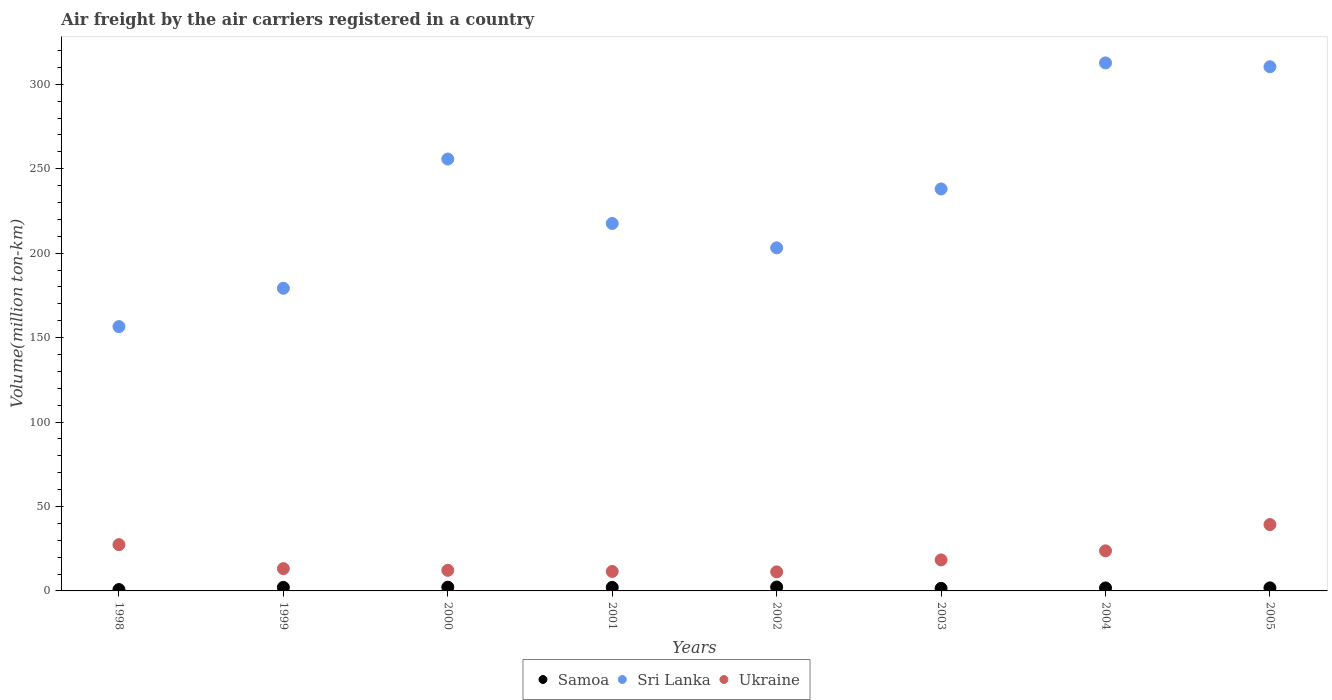How many different coloured dotlines are there?
Provide a short and direct response. 3. Is the number of dotlines equal to the number of legend labels?
Provide a succinct answer. Yes. What is the volume of the air carriers in Ukraine in 2001?
Your answer should be very brief. 11.52. Across all years, what is the maximum volume of the air carriers in Samoa?
Your answer should be very brief. 2.31. Across all years, what is the minimum volume of the air carriers in Sri Lanka?
Provide a succinct answer. 156.5. In which year was the volume of the air carriers in Samoa maximum?
Offer a very short reply. 2002. What is the total volume of the air carriers in Ukraine in the graph?
Keep it short and to the point. 156.99. What is the difference between the volume of the air carriers in Sri Lanka in 2001 and that in 2002?
Give a very brief answer. 14.44. What is the difference between the volume of the air carriers in Ukraine in 1998 and the volume of the air carriers in Samoa in 2002?
Your answer should be very brief. 25.09. What is the average volume of the air carriers in Samoa per year?
Your answer should be compact. 1.82. In the year 1999, what is the difference between the volume of the air carriers in Ukraine and volume of the air carriers in Samoa?
Keep it short and to the point. 11.1. What is the ratio of the volume of the air carriers in Samoa in 1999 to that in 2000?
Keep it short and to the point. 0.94. Is the volume of the air carriers in Ukraine in 1999 less than that in 2005?
Ensure brevity in your answer.  Yes. Is the difference between the volume of the air carriers in Ukraine in 2003 and 2004 greater than the difference between the volume of the air carriers in Samoa in 2003 and 2004?
Keep it short and to the point. No. What is the difference between the highest and the second highest volume of the air carriers in Sri Lanka?
Offer a terse response. 2.26. What is the difference between the highest and the lowest volume of the air carriers in Ukraine?
Provide a succinct answer. 28.01. In how many years, is the volume of the air carriers in Ukraine greater than the average volume of the air carriers in Ukraine taken over all years?
Keep it short and to the point. 3. Is it the case that in every year, the sum of the volume of the air carriers in Sri Lanka and volume of the air carriers in Samoa  is greater than the volume of the air carriers in Ukraine?
Keep it short and to the point. Yes. How many dotlines are there?
Offer a very short reply. 3. Are the values on the major ticks of Y-axis written in scientific E-notation?
Give a very brief answer. No. Does the graph contain any zero values?
Make the answer very short. No. Where does the legend appear in the graph?
Ensure brevity in your answer.  Bottom center. How many legend labels are there?
Give a very brief answer. 3. What is the title of the graph?
Offer a terse response. Air freight by the air carriers registered in a country. Does "Sub-Saharan Africa (developing only)" appear as one of the legend labels in the graph?
Make the answer very short. No. What is the label or title of the Y-axis?
Your answer should be very brief. Volume(million ton-km). What is the Volume(million ton-km) in Samoa in 1998?
Keep it short and to the point. 0.8. What is the Volume(million ton-km) of Sri Lanka in 1998?
Provide a short and direct response. 156.5. What is the Volume(million ton-km) in Ukraine in 1998?
Offer a terse response. 27.4. What is the Volume(million ton-km) of Samoa in 1999?
Make the answer very short. 2.1. What is the Volume(million ton-km) in Sri Lanka in 1999?
Provide a short and direct response. 179.2. What is the Volume(million ton-km) of Ukraine in 1999?
Your answer should be compact. 13.2. What is the Volume(million ton-km) of Samoa in 2000?
Your answer should be very brief. 2.23. What is the Volume(million ton-km) of Sri Lanka in 2000?
Your answer should be compact. 255.71. What is the Volume(million ton-km) in Ukraine in 2000?
Keep it short and to the point. 12.2. What is the Volume(million ton-km) in Samoa in 2001?
Offer a very short reply. 2.08. What is the Volume(million ton-km) in Sri Lanka in 2001?
Offer a very short reply. 217.57. What is the Volume(million ton-km) in Ukraine in 2001?
Keep it short and to the point. 11.52. What is the Volume(million ton-km) in Samoa in 2002?
Your answer should be very brief. 2.31. What is the Volume(million ton-km) in Sri Lanka in 2002?
Provide a succinct answer. 203.13. What is the Volume(million ton-km) in Ukraine in 2002?
Give a very brief answer. 11.28. What is the Volume(million ton-km) in Samoa in 2003?
Your response must be concise. 1.5. What is the Volume(million ton-km) of Sri Lanka in 2003?
Your answer should be compact. 238.01. What is the Volume(million ton-km) of Ukraine in 2003?
Your response must be concise. 18.36. What is the Volume(million ton-km) of Samoa in 2004?
Your response must be concise. 1.75. What is the Volume(million ton-km) in Sri Lanka in 2004?
Offer a very short reply. 312.63. What is the Volume(million ton-km) in Ukraine in 2004?
Ensure brevity in your answer.  23.73. What is the Volume(million ton-km) of Samoa in 2005?
Your response must be concise. 1.81. What is the Volume(million ton-km) of Sri Lanka in 2005?
Keep it short and to the point. 310.36. What is the Volume(million ton-km) of Ukraine in 2005?
Keep it short and to the point. 39.29. Across all years, what is the maximum Volume(million ton-km) of Samoa?
Offer a terse response. 2.31. Across all years, what is the maximum Volume(million ton-km) of Sri Lanka?
Your answer should be very brief. 312.63. Across all years, what is the maximum Volume(million ton-km) of Ukraine?
Your answer should be compact. 39.29. Across all years, what is the minimum Volume(million ton-km) in Samoa?
Provide a short and direct response. 0.8. Across all years, what is the minimum Volume(million ton-km) in Sri Lanka?
Make the answer very short. 156.5. Across all years, what is the minimum Volume(million ton-km) of Ukraine?
Provide a succinct answer. 11.28. What is the total Volume(million ton-km) in Samoa in the graph?
Make the answer very short. 14.58. What is the total Volume(million ton-km) of Sri Lanka in the graph?
Keep it short and to the point. 1873.1. What is the total Volume(million ton-km) of Ukraine in the graph?
Offer a terse response. 156.99. What is the difference between the Volume(million ton-km) in Samoa in 1998 and that in 1999?
Provide a succinct answer. -1.3. What is the difference between the Volume(million ton-km) in Sri Lanka in 1998 and that in 1999?
Keep it short and to the point. -22.7. What is the difference between the Volume(million ton-km) of Samoa in 1998 and that in 2000?
Offer a terse response. -1.43. What is the difference between the Volume(million ton-km) in Sri Lanka in 1998 and that in 2000?
Offer a very short reply. -99.21. What is the difference between the Volume(million ton-km) of Ukraine in 1998 and that in 2000?
Make the answer very short. 15.21. What is the difference between the Volume(million ton-km) in Samoa in 1998 and that in 2001?
Provide a short and direct response. -1.28. What is the difference between the Volume(million ton-km) of Sri Lanka in 1998 and that in 2001?
Provide a short and direct response. -61.07. What is the difference between the Volume(million ton-km) of Ukraine in 1998 and that in 2001?
Keep it short and to the point. 15.88. What is the difference between the Volume(million ton-km) of Samoa in 1998 and that in 2002?
Provide a short and direct response. -1.51. What is the difference between the Volume(million ton-km) in Sri Lanka in 1998 and that in 2002?
Your answer should be compact. -46.63. What is the difference between the Volume(million ton-km) of Ukraine in 1998 and that in 2002?
Offer a very short reply. 16.12. What is the difference between the Volume(million ton-km) of Samoa in 1998 and that in 2003?
Provide a short and direct response. -0.69. What is the difference between the Volume(million ton-km) of Sri Lanka in 1998 and that in 2003?
Provide a short and direct response. -81.51. What is the difference between the Volume(million ton-km) of Ukraine in 1998 and that in 2003?
Your answer should be compact. 9.04. What is the difference between the Volume(million ton-km) of Samoa in 1998 and that in 2004?
Your response must be concise. -0.95. What is the difference between the Volume(million ton-km) in Sri Lanka in 1998 and that in 2004?
Provide a succinct answer. -156.13. What is the difference between the Volume(million ton-km) of Ukraine in 1998 and that in 2004?
Your answer should be compact. 3.67. What is the difference between the Volume(million ton-km) of Samoa in 1998 and that in 2005?
Your answer should be very brief. -1.01. What is the difference between the Volume(million ton-km) in Sri Lanka in 1998 and that in 2005?
Offer a very short reply. -153.86. What is the difference between the Volume(million ton-km) of Ukraine in 1998 and that in 2005?
Your response must be concise. -11.89. What is the difference between the Volume(million ton-km) of Samoa in 1999 and that in 2000?
Offer a terse response. -0.13. What is the difference between the Volume(million ton-km) in Sri Lanka in 1999 and that in 2000?
Provide a succinct answer. -76.51. What is the difference between the Volume(million ton-km) in Ukraine in 1999 and that in 2000?
Ensure brevity in your answer.  1. What is the difference between the Volume(million ton-km) of Samoa in 1999 and that in 2001?
Offer a very short reply. 0.02. What is the difference between the Volume(million ton-km) of Sri Lanka in 1999 and that in 2001?
Ensure brevity in your answer.  -38.37. What is the difference between the Volume(million ton-km) in Ukraine in 1999 and that in 2001?
Keep it short and to the point. 1.68. What is the difference between the Volume(million ton-km) of Samoa in 1999 and that in 2002?
Provide a succinct answer. -0.21. What is the difference between the Volume(million ton-km) of Sri Lanka in 1999 and that in 2002?
Your answer should be very brief. -23.93. What is the difference between the Volume(million ton-km) in Ukraine in 1999 and that in 2002?
Provide a short and direct response. 1.92. What is the difference between the Volume(million ton-km) in Samoa in 1999 and that in 2003?
Provide a succinct answer. 0.6. What is the difference between the Volume(million ton-km) of Sri Lanka in 1999 and that in 2003?
Ensure brevity in your answer.  -58.81. What is the difference between the Volume(million ton-km) in Ukraine in 1999 and that in 2003?
Give a very brief answer. -5.16. What is the difference between the Volume(million ton-km) of Sri Lanka in 1999 and that in 2004?
Provide a short and direct response. -133.43. What is the difference between the Volume(million ton-km) in Ukraine in 1999 and that in 2004?
Provide a succinct answer. -10.53. What is the difference between the Volume(million ton-km) in Samoa in 1999 and that in 2005?
Your response must be concise. 0.29. What is the difference between the Volume(million ton-km) of Sri Lanka in 1999 and that in 2005?
Ensure brevity in your answer.  -131.16. What is the difference between the Volume(million ton-km) of Ukraine in 1999 and that in 2005?
Keep it short and to the point. -26.09. What is the difference between the Volume(million ton-km) in Samoa in 2000 and that in 2001?
Give a very brief answer. 0.14. What is the difference between the Volume(million ton-km) in Sri Lanka in 2000 and that in 2001?
Ensure brevity in your answer.  38.14. What is the difference between the Volume(million ton-km) in Ukraine in 2000 and that in 2001?
Your response must be concise. 0.67. What is the difference between the Volume(million ton-km) of Samoa in 2000 and that in 2002?
Ensure brevity in your answer.  -0.09. What is the difference between the Volume(million ton-km) of Sri Lanka in 2000 and that in 2002?
Give a very brief answer. 52.58. What is the difference between the Volume(million ton-km) in Ukraine in 2000 and that in 2002?
Offer a very short reply. 0.91. What is the difference between the Volume(million ton-km) in Samoa in 2000 and that in 2003?
Keep it short and to the point. 0.73. What is the difference between the Volume(million ton-km) of Sri Lanka in 2000 and that in 2003?
Give a very brief answer. 17.7. What is the difference between the Volume(million ton-km) of Ukraine in 2000 and that in 2003?
Ensure brevity in your answer.  -6.16. What is the difference between the Volume(million ton-km) of Samoa in 2000 and that in 2004?
Offer a very short reply. 0.48. What is the difference between the Volume(million ton-km) in Sri Lanka in 2000 and that in 2004?
Give a very brief answer. -56.92. What is the difference between the Volume(million ton-km) in Ukraine in 2000 and that in 2004?
Keep it short and to the point. -11.54. What is the difference between the Volume(million ton-km) of Samoa in 2000 and that in 2005?
Make the answer very short. 0.42. What is the difference between the Volume(million ton-km) in Sri Lanka in 2000 and that in 2005?
Ensure brevity in your answer.  -54.65. What is the difference between the Volume(million ton-km) in Ukraine in 2000 and that in 2005?
Your answer should be compact. -27.1. What is the difference between the Volume(million ton-km) in Samoa in 2001 and that in 2002?
Ensure brevity in your answer.  -0.23. What is the difference between the Volume(million ton-km) in Sri Lanka in 2001 and that in 2002?
Your answer should be compact. 14.44. What is the difference between the Volume(million ton-km) in Ukraine in 2001 and that in 2002?
Make the answer very short. 0.24. What is the difference between the Volume(million ton-km) of Samoa in 2001 and that in 2003?
Your answer should be compact. 0.59. What is the difference between the Volume(million ton-km) of Sri Lanka in 2001 and that in 2003?
Make the answer very short. -20.44. What is the difference between the Volume(million ton-km) in Ukraine in 2001 and that in 2003?
Your answer should be compact. -6.84. What is the difference between the Volume(million ton-km) of Samoa in 2001 and that in 2004?
Provide a succinct answer. 0.33. What is the difference between the Volume(million ton-km) in Sri Lanka in 2001 and that in 2004?
Provide a succinct answer. -95.06. What is the difference between the Volume(million ton-km) of Ukraine in 2001 and that in 2004?
Your response must be concise. -12.21. What is the difference between the Volume(million ton-km) in Samoa in 2001 and that in 2005?
Provide a succinct answer. 0.27. What is the difference between the Volume(million ton-km) of Sri Lanka in 2001 and that in 2005?
Your answer should be very brief. -92.8. What is the difference between the Volume(million ton-km) of Ukraine in 2001 and that in 2005?
Your answer should be very brief. -27.77. What is the difference between the Volume(million ton-km) in Samoa in 2002 and that in 2003?
Keep it short and to the point. 0.82. What is the difference between the Volume(million ton-km) in Sri Lanka in 2002 and that in 2003?
Provide a short and direct response. -34.88. What is the difference between the Volume(million ton-km) of Ukraine in 2002 and that in 2003?
Your answer should be very brief. -7.08. What is the difference between the Volume(million ton-km) in Samoa in 2002 and that in 2004?
Offer a very short reply. 0.56. What is the difference between the Volume(million ton-km) in Sri Lanka in 2002 and that in 2004?
Your response must be concise. -109.5. What is the difference between the Volume(million ton-km) of Ukraine in 2002 and that in 2004?
Offer a terse response. -12.45. What is the difference between the Volume(million ton-km) in Samoa in 2002 and that in 2005?
Offer a terse response. 0.5. What is the difference between the Volume(million ton-km) of Sri Lanka in 2002 and that in 2005?
Offer a terse response. -107.24. What is the difference between the Volume(million ton-km) in Ukraine in 2002 and that in 2005?
Your answer should be compact. -28.01. What is the difference between the Volume(million ton-km) of Samoa in 2003 and that in 2004?
Ensure brevity in your answer.  -0.26. What is the difference between the Volume(million ton-km) of Sri Lanka in 2003 and that in 2004?
Offer a very short reply. -74.62. What is the difference between the Volume(million ton-km) of Ukraine in 2003 and that in 2004?
Ensure brevity in your answer.  -5.38. What is the difference between the Volume(million ton-km) of Samoa in 2003 and that in 2005?
Provide a short and direct response. -0.31. What is the difference between the Volume(million ton-km) in Sri Lanka in 2003 and that in 2005?
Make the answer very short. -72.35. What is the difference between the Volume(million ton-km) in Ukraine in 2003 and that in 2005?
Provide a short and direct response. -20.93. What is the difference between the Volume(million ton-km) in Samoa in 2004 and that in 2005?
Offer a terse response. -0.06. What is the difference between the Volume(million ton-km) in Sri Lanka in 2004 and that in 2005?
Provide a short and direct response. 2.27. What is the difference between the Volume(million ton-km) of Ukraine in 2004 and that in 2005?
Your response must be concise. -15.56. What is the difference between the Volume(million ton-km) in Samoa in 1998 and the Volume(million ton-km) in Sri Lanka in 1999?
Make the answer very short. -178.4. What is the difference between the Volume(million ton-km) of Samoa in 1998 and the Volume(million ton-km) of Ukraine in 1999?
Your answer should be very brief. -12.4. What is the difference between the Volume(million ton-km) of Sri Lanka in 1998 and the Volume(million ton-km) of Ukraine in 1999?
Your answer should be compact. 143.3. What is the difference between the Volume(million ton-km) in Samoa in 1998 and the Volume(million ton-km) in Sri Lanka in 2000?
Provide a succinct answer. -254.91. What is the difference between the Volume(million ton-km) in Samoa in 1998 and the Volume(million ton-km) in Ukraine in 2000?
Keep it short and to the point. -11.39. What is the difference between the Volume(million ton-km) in Sri Lanka in 1998 and the Volume(million ton-km) in Ukraine in 2000?
Your answer should be very brief. 144.31. What is the difference between the Volume(million ton-km) of Samoa in 1998 and the Volume(million ton-km) of Sri Lanka in 2001?
Your answer should be very brief. -216.77. What is the difference between the Volume(million ton-km) in Samoa in 1998 and the Volume(million ton-km) in Ukraine in 2001?
Provide a short and direct response. -10.72. What is the difference between the Volume(million ton-km) of Sri Lanka in 1998 and the Volume(million ton-km) of Ukraine in 2001?
Ensure brevity in your answer.  144.98. What is the difference between the Volume(million ton-km) in Samoa in 1998 and the Volume(million ton-km) in Sri Lanka in 2002?
Give a very brief answer. -202.33. What is the difference between the Volume(million ton-km) of Samoa in 1998 and the Volume(million ton-km) of Ukraine in 2002?
Your response must be concise. -10.48. What is the difference between the Volume(million ton-km) in Sri Lanka in 1998 and the Volume(million ton-km) in Ukraine in 2002?
Provide a short and direct response. 145.22. What is the difference between the Volume(million ton-km) of Samoa in 1998 and the Volume(million ton-km) of Sri Lanka in 2003?
Give a very brief answer. -237.21. What is the difference between the Volume(million ton-km) of Samoa in 1998 and the Volume(million ton-km) of Ukraine in 2003?
Your answer should be very brief. -17.56. What is the difference between the Volume(million ton-km) in Sri Lanka in 1998 and the Volume(million ton-km) in Ukraine in 2003?
Keep it short and to the point. 138.14. What is the difference between the Volume(million ton-km) of Samoa in 1998 and the Volume(million ton-km) of Sri Lanka in 2004?
Give a very brief answer. -311.83. What is the difference between the Volume(million ton-km) of Samoa in 1998 and the Volume(million ton-km) of Ukraine in 2004?
Keep it short and to the point. -22.93. What is the difference between the Volume(million ton-km) of Sri Lanka in 1998 and the Volume(million ton-km) of Ukraine in 2004?
Make the answer very short. 132.77. What is the difference between the Volume(million ton-km) of Samoa in 1998 and the Volume(million ton-km) of Sri Lanka in 2005?
Your answer should be very brief. -309.56. What is the difference between the Volume(million ton-km) of Samoa in 1998 and the Volume(million ton-km) of Ukraine in 2005?
Provide a succinct answer. -38.49. What is the difference between the Volume(million ton-km) in Sri Lanka in 1998 and the Volume(million ton-km) in Ukraine in 2005?
Your response must be concise. 117.21. What is the difference between the Volume(million ton-km) of Samoa in 1999 and the Volume(million ton-km) of Sri Lanka in 2000?
Your answer should be compact. -253.61. What is the difference between the Volume(million ton-km) of Samoa in 1999 and the Volume(million ton-km) of Ukraine in 2000?
Provide a succinct answer. -10.1. What is the difference between the Volume(million ton-km) in Sri Lanka in 1999 and the Volume(million ton-km) in Ukraine in 2000?
Your answer should be very brief. 167. What is the difference between the Volume(million ton-km) in Samoa in 1999 and the Volume(million ton-km) in Sri Lanka in 2001?
Your response must be concise. -215.47. What is the difference between the Volume(million ton-km) in Samoa in 1999 and the Volume(million ton-km) in Ukraine in 2001?
Ensure brevity in your answer.  -9.42. What is the difference between the Volume(million ton-km) of Sri Lanka in 1999 and the Volume(million ton-km) of Ukraine in 2001?
Give a very brief answer. 167.68. What is the difference between the Volume(million ton-km) in Samoa in 1999 and the Volume(million ton-km) in Sri Lanka in 2002?
Make the answer very short. -201.03. What is the difference between the Volume(million ton-km) in Samoa in 1999 and the Volume(million ton-km) in Ukraine in 2002?
Provide a short and direct response. -9.18. What is the difference between the Volume(million ton-km) in Sri Lanka in 1999 and the Volume(million ton-km) in Ukraine in 2002?
Provide a succinct answer. 167.92. What is the difference between the Volume(million ton-km) in Samoa in 1999 and the Volume(million ton-km) in Sri Lanka in 2003?
Offer a terse response. -235.91. What is the difference between the Volume(million ton-km) of Samoa in 1999 and the Volume(million ton-km) of Ukraine in 2003?
Offer a very short reply. -16.26. What is the difference between the Volume(million ton-km) of Sri Lanka in 1999 and the Volume(million ton-km) of Ukraine in 2003?
Provide a short and direct response. 160.84. What is the difference between the Volume(million ton-km) in Samoa in 1999 and the Volume(million ton-km) in Sri Lanka in 2004?
Make the answer very short. -310.53. What is the difference between the Volume(million ton-km) of Samoa in 1999 and the Volume(million ton-km) of Ukraine in 2004?
Your response must be concise. -21.63. What is the difference between the Volume(million ton-km) of Sri Lanka in 1999 and the Volume(million ton-km) of Ukraine in 2004?
Your response must be concise. 155.47. What is the difference between the Volume(million ton-km) of Samoa in 1999 and the Volume(million ton-km) of Sri Lanka in 2005?
Offer a terse response. -308.26. What is the difference between the Volume(million ton-km) of Samoa in 1999 and the Volume(million ton-km) of Ukraine in 2005?
Give a very brief answer. -37.19. What is the difference between the Volume(million ton-km) of Sri Lanka in 1999 and the Volume(million ton-km) of Ukraine in 2005?
Your answer should be very brief. 139.91. What is the difference between the Volume(million ton-km) in Samoa in 2000 and the Volume(million ton-km) in Sri Lanka in 2001?
Your response must be concise. -215.34. What is the difference between the Volume(million ton-km) in Samoa in 2000 and the Volume(million ton-km) in Ukraine in 2001?
Your answer should be compact. -9.29. What is the difference between the Volume(million ton-km) in Sri Lanka in 2000 and the Volume(million ton-km) in Ukraine in 2001?
Your answer should be very brief. 244.19. What is the difference between the Volume(million ton-km) in Samoa in 2000 and the Volume(million ton-km) in Sri Lanka in 2002?
Offer a terse response. -200.9. What is the difference between the Volume(million ton-km) in Samoa in 2000 and the Volume(million ton-km) in Ukraine in 2002?
Your response must be concise. -9.06. What is the difference between the Volume(million ton-km) of Sri Lanka in 2000 and the Volume(million ton-km) of Ukraine in 2002?
Keep it short and to the point. 244.42. What is the difference between the Volume(million ton-km) in Samoa in 2000 and the Volume(million ton-km) in Sri Lanka in 2003?
Your answer should be very brief. -235.78. What is the difference between the Volume(million ton-km) of Samoa in 2000 and the Volume(million ton-km) of Ukraine in 2003?
Your answer should be compact. -16.13. What is the difference between the Volume(million ton-km) in Sri Lanka in 2000 and the Volume(million ton-km) in Ukraine in 2003?
Offer a terse response. 237.35. What is the difference between the Volume(million ton-km) of Samoa in 2000 and the Volume(million ton-km) of Sri Lanka in 2004?
Keep it short and to the point. -310.4. What is the difference between the Volume(million ton-km) of Samoa in 2000 and the Volume(million ton-km) of Ukraine in 2004?
Keep it short and to the point. -21.51. What is the difference between the Volume(million ton-km) of Sri Lanka in 2000 and the Volume(million ton-km) of Ukraine in 2004?
Offer a very short reply. 231.97. What is the difference between the Volume(million ton-km) of Samoa in 2000 and the Volume(million ton-km) of Sri Lanka in 2005?
Offer a very short reply. -308.13. What is the difference between the Volume(million ton-km) in Samoa in 2000 and the Volume(million ton-km) in Ukraine in 2005?
Your answer should be very brief. -37.07. What is the difference between the Volume(million ton-km) of Sri Lanka in 2000 and the Volume(million ton-km) of Ukraine in 2005?
Provide a short and direct response. 216.41. What is the difference between the Volume(million ton-km) of Samoa in 2001 and the Volume(million ton-km) of Sri Lanka in 2002?
Your answer should be very brief. -201.04. What is the difference between the Volume(million ton-km) of Samoa in 2001 and the Volume(million ton-km) of Ukraine in 2002?
Provide a short and direct response. -9.2. What is the difference between the Volume(million ton-km) of Sri Lanka in 2001 and the Volume(million ton-km) of Ukraine in 2002?
Your answer should be compact. 206.28. What is the difference between the Volume(million ton-km) of Samoa in 2001 and the Volume(million ton-km) of Sri Lanka in 2003?
Your answer should be compact. -235.93. What is the difference between the Volume(million ton-km) in Samoa in 2001 and the Volume(million ton-km) in Ukraine in 2003?
Provide a short and direct response. -16.28. What is the difference between the Volume(million ton-km) in Sri Lanka in 2001 and the Volume(million ton-km) in Ukraine in 2003?
Provide a short and direct response. 199.21. What is the difference between the Volume(million ton-km) of Samoa in 2001 and the Volume(million ton-km) of Sri Lanka in 2004?
Provide a short and direct response. -310.54. What is the difference between the Volume(million ton-km) in Samoa in 2001 and the Volume(million ton-km) in Ukraine in 2004?
Your answer should be compact. -21.65. What is the difference between the Volume(million ton-km) of Sri Lanka in 2001 and the Volume(million ton-km) of Ukraine in 2004?
Offer a very short reply. 193.83. What is the difference between the Volume(million ton-km) of Samoa in 2001 and the Volume(million ton-km) of Sri Lanka in 2005?
Keep it short and to the point. -308.28. What is the difference between the Volume(million ton-km) in Samoa in 2001 and the Volume(million ton-km) in Ukraine in 2005?
Your answer should be very brief. -37.21. What is the difference between the Volume(million ton-km) of Sri Lanka in 2001 and the Volume(million ton-km) of Ukraine in 2005?
Provide a succinct answer. 178.27. What is the difference between the Volume(million ton-km) in Samoa in 2002 and the Volume(million ton-km) in Sri Lanka in 2003?
Ensure brevity in your answer.  -235.7. What is the difference between the Volume(million ton-km) in Samoa in 2002 and the Volume(million ton-km) in Ukraine in 2003?
Your answer should be compact. -16.05. What is the difference between the Volume(million ton-km) in Sri Lanka in 2002 and the Volume(million ton-km) in Ukraine in 2003?
Provide a succinct answer. 184.77. What is the difference between the Volume(million ton-km) in Samoa in 2002 and the Volume(million ton-km) in Sri Lanka in 2004?
Ensure brevity in your answer.  -310.31. What is the difference between the Volume(million ton-km) in Samoa in 2002 and the Volume(million ton-km) in Ukraine in 2004?
Your answer should be very brief. -21.42. What is the difference between the Volume(million ton-km) in Sri Lanka in 2002 and the Volume(million ton-km) in Ukraine in 2004?
Give a very brief answer. 179.39. What is the difference between the Volume(million ton-km) of Samoa in 2002 and the Volume(million ton-km) of Sri Lanka in 2005?
Provide a short and direct response. -308.05. What is the difference between the Volume(million ton-km) of Samoa in 2002 and the Volume(million ton-km) of Ukraine in 2005?
Make the answer very short. -36.98. What is the difference between the Volume(million ton-km) of Sri Lanka in 2002 and the Volume(million ton-km) of Ukraine in 2005?
Make the answer very short. 163.83. What is the difference between the Volume(million ton-km) in Samoa in 2003 and the Volume(million ton-km) in Sri Lanka in 2004?
Keep it short and to the point. -311.13. What is the difference between the Volume(million ton-km) of Samoa in 2003 and the Volume(million ton-km) of Ukraine in 2004?
Ensure brevity in your answer.  -22.24. What is the difference between the Volume(million ton-km) in Sri Lanka in 2003 and the Volume(million ton-km) in Ukraine in 2004?
Your response must be concise. 214.28. What is the difference between the Volume(million ton-km) of Samoa in 2003 and the Volume(million ton-km) of Sri Lanka in 2005?
Keep it short and to the point. -308.87. What is the difference between the Volume(million ton-km) in Samoa in 2003 and the Volume(million ton-km) in Ukraine in 2005?
Your answer should be very brief. -37.8. What is the difference between the Volume(million ton-km) in Sri Lanka in 2003 and the Volume(million ton-km) in Ukraine in 2005?
Offer a terse response. 198.72. What is the difference between the Volume(million ton-km) of Samoa in 2004 and the Volume(million ton-km) of Sri Lanka in 2005?
Provide a succinct answer. -308.61. What is the difference between the Volume(million ton-km) of Samoa in 2004 and the Volume(million ton-km) of Ukraine in 2005?
Offer a very short reply. -37.54. What is the difference between the Volume(million ton-km) of Sri Lanka in 2004 and the Volume(million ton-km) of Ukraine in 2005?
Make the answer very short. 273.33. What is the average Volume(million ton-km) of Samoa per year?
Provide a succinct answer. 1.82. What is the average Volume(million ton-km) of Sri Lanka per year?
Provide a succinct answer. 234.14. What is the average Volume(million ton-km) in Ukraine per year?
Your answer should be very brief. 19.62. In the year 1998, what is the difference between the Volume(million ton-km) in Samoa and Volume(million ton-km) in Sri Lanka?
Provide a succinct answer. -155.7. In the year 1998, what is the difference between the Volume(million ton-km) in Samoa and Volume(million ton-km) in Ukraine?
Make the answer very short. -26.6. In the year 1998, what is the difference between the Volume(million ton-km) of Sri Lanka and Volume(million ton-km) of Ukraine?
Make the answer very short. 129.1. In the year 1999, what is the difference between the Volume(million ton-km) of Samoa and Volume(million ton-km) of Sri Lanka?
Your answer should be compact. -177.1. In the year 1999, what is the difference between the Volume(million ton-km) of Sri Lanka and Volume(million ton-km) of Ukraine?
Give a very brief answer. 166. In the year 2000, what is the difference between the Volume(million ton-km) in Samoa and Volume(million ton-km) in Sri Lanka?
Provide a succinct answer. -253.48. In the year 2000, what is the difference between the Volume(million ton-km) of Samoa and Volume(million ton-km) of Ukraine?
Ensure brevity in your answer.  -9.97. In the year 2000, what is the difference between the Volume(million ton-km) of Sri Lanka and Volume(million ton-km) of Ukraine?
Provide a short and direct response. 243.51. In the year 2001, what is the difference between the Volume(million ton-km) in Samoa and Volume(million ton-km) in Sri Lanka?
Your answer should be compact. -215.48. In the year 2001, what is the difference between the Volume(million ton-km) of Samoa and Volume(million ton-km) of Ukraine?
Your response must be concise. -9.44. In the year 2001, what is the difference between the Volume(million ton-km) in Sri Lanka and Volume(million ton-km) in Ukraine?
Keep it short and to the point. 206.04. In the year 2002, what is the difference between the Volume(million ton-km) in Samoa and Volume(million ton-km) in Sri Lanka?
Offer a very short reply. -200.81. In the year 2002, what is the difference between the Volume(million ton-km) in Samoa and Volume(million ton-km) in Ukraine?
Give a very brief answer. -8.97. In the year 2002, what is the difference between the Volume(million ton-km) in Sri Lanka and Volume(million ton-km) in Ukraine?
Make the answer very short. 191.84. In the year 2003, what is the difference between the Volume(million ton-km) in Samoa and Volume(million ton-km) in Sri Lanka?
Give a very brief answer. -236.51. In the year 2003, what is the difference between the Volume(million ton-km) in Samoa and Volume(million ton-km) in Ukraine?
Provide a succinct answer. -16.86. In the year 2003, what is the difference between the Volume(million ton-km) in Sri Lanka and Volume(million ton-km) in Ukraine?
Ensure brevity in your answer.  219.65. In the year 2004, what is the difference between the Volume(million ton-km) of Samoa and Volume(million ton-km) of Sri Lanka?
Your response must be concise. -310.88. In the year 2004, what is the difference between the Volume(million ton-km) of Samoa and Volume(million ton-km) of Ukraine?
Ensure brevity in your answer.  -21.98. In the year 2004, what is the difference between the Volume(million ton-km) of Sri Lanka and Volume(million ton-km) of Ukraine?
Offer a very short reply. 288.89. In the year 2005, what is the difference between the Volume(million ton-km) of Samoa and Volume(million ton-km) of Sri Lanka?
Your response must be concise. -308.55. In the year 2005, what is the difference between the Volume(million ton-km) of Samoa and Volume(million ton-km) of Ukraine?
Offer a very short reply. -37.48. In the year 2005, what is the difference between the Volume(million ton-km) in Sri Lanka and Volume(million ton-km) in Ukraine?
Offer a very short reply. 271.07. What is the ratio of the Volume(million ton-km) of Samoa in 1998 to that in 1999?
Give a very brief answer. 0.38. What is the ratio of the Volume(million ton-km) in Sri Lanka in 1998 to that in 1999?
Make the answer very short. 0.87. What is the ratio of the Volume(million ton-km) of Ukraine in 1998 to that in 1999?
Your response must be concise. 2.08. What is the ratio of the Volume(million ton-km) in Samoa in 1998 to that in 2000?
Provide a short and direct response. 0.36. What is the ratio of the Volume(million ton-km) in Sri Lanka in 1998 to that in 2000?
Offer a very short reply. 0.61. What is the ratio of the Volume(million ton-km) in Ukraine in 1998 to that in 2000?
Offer a very short reply. 2.25. What is the ratio of the Volume(million ton-km) in Samoa in 1998 to that in 2001?
Your answer should be compact. 0.38. What is the ratio of the Volume(million ton-km) in Sri Lanka in 1998 to that in 2001?
Provide a short and direct response. 0.72. What is the ratio of the Volume(million ton-km) in Ukraine in 1998 to that in 2001?
Your response must be concise. 2.38. What is the ratio of the Volume(million ton-km) in Samoa in 1998 to that in 2002?
Give a very brief answer. 0.35. What is the ratio of the Volume(million ton-km) in Sri Lanka in 1998 to that in 2002?
Provide a short and direct response. 0.77. What is the ratio of the Volume(million ton-km) in Ukraine in 1998 to that in 2002?
Your answer should be very brief. 2.43. What is the ratio of the Volume(million ton-km) in Samoa in 1998 to that in 2003?
Provide a succinct answer. 0.54. What is the ratio of the Volume(million ton-km) in Sri Lanka in 1998 to that in 2003?
Your answer should be very brief. 0.66. What is the ratio of the Volume(million ton-km) of Ukraine in 1998 to that in 2003?
Give a very brief answer. 1.49. What is the ratio of the Volume(million ton-km) of Samoa in 1998 to that in 2004?
Offer a very short reply. 0.46. What is the ratio of the Volume(million ton-km) of Sri Lanka in 1998 to that in 2004?
Provide a succinct answer. 0.5. What is the ratio of the Volume(million ton-km) in Ukraine in 1998 to that in 2004?
Give a very brief answer. 1.15. What is the ratio of the Volume(million ton-km) of Samoa in 1998 to that in 2005?
Make the answer very short. 0.44. What is the ratio of the Volume(million ton-km) of Sri Lanka in 1998 to that in 2005?
Provide a succinct answer. 0.5. What is the ratio of the Volume(million ton-km) in Ukraine in 1998 to that in 2005?
Make the answer very short. 0.7. What is the ratio of the Volume(million ton-km) in Samoa in 1999 to that in 2000?
Give a very brief answer. 0.94. What is the ratio of the Volume(million ton-km) of Sri Lanka in 1999 to that in 2000?
Your response must be concise. 0.7. What is the ratio of the Volume(million ton-km) of Ukraine in 1999 to that in 2000?
Your response must be concise. 1.08. What is the ratio of the Volume(million ton-km) in Samoa in 1999 to that in 2001?
Offer a terse response. 1.01. What is the ratio of the Volume(million ton-km) of Sri Lanka in 1999 to that in 2001?
Keep it short and to the point. 0.82. What is the ratio of the Volume(million ton-km) of Ukraine in 1999 to that in 2001?
Give a very brief answer. 1.15. What is the ratio of the Volume(million ton-km) of Samoa in 1999 to that in 2002?
Your answer should be very brief. 0.91. What is the ratio of the Volume(million ton-km) in Sri Lanka in 1999 to that in 2002?
Give a very brief answer. 0.88. What is the ratio of the Volume(million ton-km) in Ukraine in 1999 to that in 2002?
Offer a very short reply. 1.17. What is the ratio of the Volume(million ton-km) of Samoa in 1999 to that in 2003?
Give a very brief answer. 1.4. What is the ratio of the Volume(million ton-km) of Sri Lanka in 1999 to that in 2003?
Offer a terse response. 0.75. What is the ratio of the Volume(million ton-km) of Ukraine in 1999 to that in 2003?
Your answer should be very brief. 0.72. What is the ratio of the Volume(million ton-km) of Sri Lanka in 1999 to that in 2004?
Give a very brief answer. 0.57. What is the ratio of the Volume(million ton-km) of Ukraine in 1999 to that in 2004?
Give a very brief answer. 0.56. What is the ratio of the Volume(million ton-km) of Samoa in 1999 to that in 2005?
Offer a very short reply. 1.16. What is the ratio of the Volume(million ton-km) of Sri Lanka in 1999 to that in 2005?
Provide a short and direct response. 0.58. What is the ratio of the Volume(million ton-km) in Ukraine in 1999 to that in 2005?
Your response must be concise. 0.34. What is the ratio of the Volume(million ton-km) in Samoa in 2000 to that in 2001?
Provide a short and direct response. 1.07. What is the ratio of the Volume(million ton-km) in Sri Lanka in 2000 to that in 2001?
Ensure brevity in your answer.  1.18. What is the ratio of the Volume(million ton-km) in Ukraine in 2000 to that in 2001?
Provide a short and direct response. 1.06. What is the ratio of the Volume(million ton-km) of Samoa in 2000 to that in 2002?
Offer a terse response. 0.96. What is the ratio of the Volume(million ton-km) of Sri Lanka in 2000 to that in 2002?
Offer a very short reply. 1.26. What is the ratio of the Volume(million ton-km) in Ukraine in 2000 to that in 2002?
Give a very brief answer. 1.08. What is the ratio of the Volume(million ton-km) of Samoa in 2000 to that in 2003?
Offer a terse response. 1.49. What is the ratio of the Volume(million ton-km) in Sri Lanka in 2000 to that in 2003?
Your response must be concise. 1.07. What is the ratio of the Volume(million ton-km) of Ukraine in 2000 to that in 2003?
Give a very brief answer. 0.66. What is the ratio of the Volume(million ton-km) of Samoa in 2000 to that in 2004?
Provide a succinct answer. 1.27. What is the ratio of the Volume(million ton-km) in Sri Lanka in 2000 to that in 2004?
Your answer should be very brief. 0.82. What is the ratio of the Volume(million ton-km) of Ukraine in 2000 to that in 2004?
Your response must be concise. 0.51. What is the ratio of the Volume(million ton-km) in Samoa in 2000 to that in 2005?
Ensure brevity in your answer.  1.23. What is the ratio of the Volume(million ton-km) of Sri Lanka in 2000 to that in 2005?
Make the answer very short. 0.82. What is the ratio of the Volume(million ton-km) of Ukraine in 2000 to that in 2005?
Provide a short and direct response. 0.31. What is the ratio of the Volume(million ton-km) in Samoa in 2001 to that in 2002?
Offer a terse response. 0.9. What is the ratio of the Volume(million ton-km) in Sri Lanka in 2001 to that in 2002?
Provide a succinct answer. 1.07. What is the ratio of the Volume(million ton-km) in Ukraine in 2001 to that in 2002?
Provide a succinct answer. 1.02. What is the ratio of the Volume(million ton-km) in Samoa in 2001 to that in 2003?
Offer a terse response. 1.39. What is the ratio of the Volume(million ton-km) of Sri Lanka in 2001 to that in 2003?
Your response must be concise. 0.91. What is the ratio of the Volume(million ton-km) in Ukraine in 2001 to that in 2003?
Provide a short and direct response. 0.63. What is the ratio of the Volume(million ton-km) of Samoa in 2001 to that in 2004?
Offer a very short reply. 1.19. What is the ratio of the Volume(million ton-km) of Sri Lanka in 2001 to that in 2004?
Your response must be concise. 0.7. What is the ratio of the Volume(million ton-km) in Ukraine in 2001 to that in 2004?
Provide a succinct answer. 0.49. What is the ratio of the Volume(million ton-km) in Samoa in 2001 to that in 2005?
Ensure brevity in your answer.  1.15. What is the ratio of the Volume(million ton-km) in Sri Lanka in 2001 to that in 2005?
Offer a very short reply. 0.7. What is the ratio of the Volume(million ton-km) in Ukraine in 2001 to that in 2005?
Your answer should be compact. 0.29. What is the ratio of the Volume(million ton-km) in Samoa in 2002 to that in 2003?
Your answer should be compact. 1.55. What is the ratio of the Volume(million ton-km) in Sri Lanka in 2002 to that in 2003?
Keep it short and to the point. 0.85. What is the ratio of the Volume(million ton-km) in Ukraine in 2002 to that in 2003?
Ensure brevity in your answer.  0.61. What is the ratio of the Volume(million ton-km) in Samoa in 2002 to that in 2004?
Offer a very short reply. 1.32. What is the ratio of the Volume(million ton-km) of Sri Lanka in 2002 to that in 2004?
Keep it short and to the point. 0.65. What is the ratio of the Volume(million ton-km) of Ukraine in 2002 to that in 2004?
Give a very brief answer. 0.48. What is the ratio of the Volume(million ton-km) in Samoa in 2002 to that in 2005?
Keep it short and to the point. 1.28. What is the ratio of the Volume(million ton-km) of Sri Lanka in 2002 to that in 2005?
Provide a succinct answer. 0.65. What is the ratio of the Volume(million ton-km) of Ukraine in 2002 to that in 2005?
Offer a terse response. 0.29. What is the ratio of the Volume(million ton-km) in Samoa in 2003 to that in 2004?
Keep it short and to the point. 0.85. What is the ratio of the Volume(million ton-km) of Sri Lanka in 2003 to that in 2004?
Ensure brevity in your answer.  0.76. What is the ratio of the Volume(million ton-km) of Ukraine in 2003 to that in 2004?
Your answer should be compact. 0.77. What is the ratio of the Volume(million ton-km) of Samoa in 2003 to that in 2005?
Your response must be concise. 0.83. What is the ratio of the Volume(million ton-km) of Sri Lanka in 2003 to that in 2005?
Provide a succinct answer. 0.77. What is the ratio of the Volume(million ton-km) of Ukraine in 2003 to that in 2005?
Provide a succinct answer. 0.47. What is the ratio of the Volume(million ton-km) of Samoa in 2004 to that in 2005?
Your response must be concise. 0.97. What is the ratio of the Volume(million ton-km) in Sri Lanka in 2004 to that in 2005?
Provide a short and direct response. 1.01. What is the ratio of the Volume(million ton-km) in Ukraine in 2004 to that in 2005?
Your answer should be compact. 0.6. What is the difference between the highest and the second highest Volume(million ton-km) in Samoa?
Your answer should be very brief. 0.09. What is the difference between the highest and the second highest Volume(million ton-km) in Sri Lanka?
Give a very brief answer. 2.27. What is the difference between the highest and the second highest Volume(million ton-km) in Ukraine?
Make the answer very short. 11.89. What is the difference between the highest and the lowest Volume(million ton-km) of Samoa?
Make the answer very short. 1.51. What is the difference between the highest and the lowest Volume(million ton-km) in Sri Lanka?
Make the answer very short. 156.13. What is the difference between the highest and the lowest Volume(million ton-km) of Ukraine?
Offer a very short reply. 28.01. 